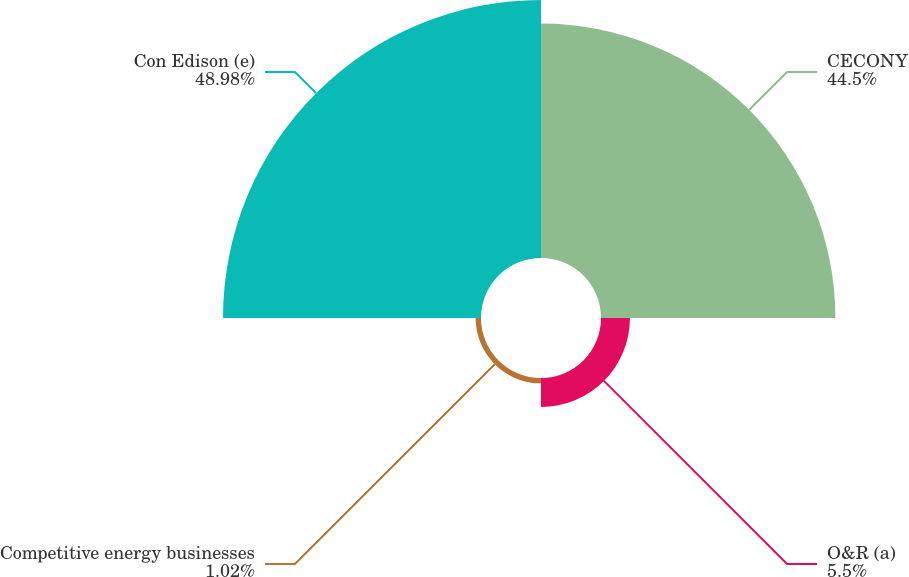Convert chart to OTSL. <chart><loc_0><loc_0><loc_500><loc_500><pie_chart><fcel>CECONY<fcel>O&R (a)<fcel>Competitive energy businesses<fcel>Con Edison (e)<nl><fcel>44.5%<fcel>5.5%<fcel>1.02%<fcel>48.98%<nl></chart> 